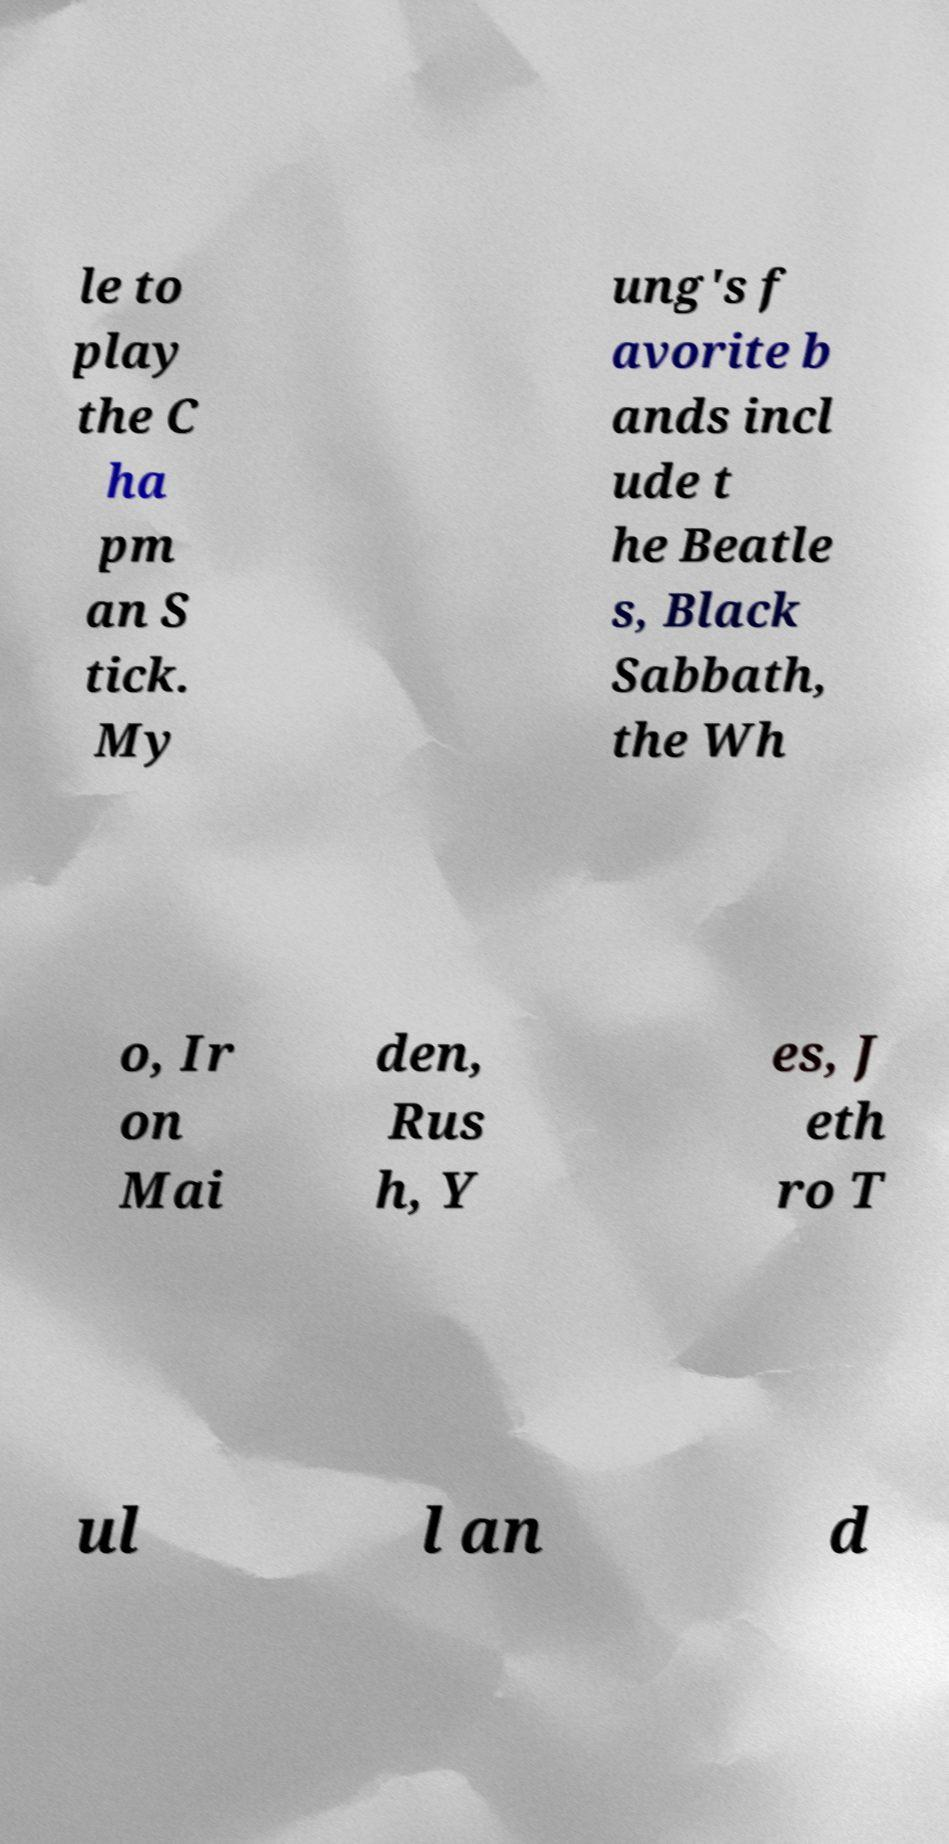Could you extract and type out the text from this image? le to play the C ha pm an S tick. My ung's f avorite b ands incl ude t he Beatle s, Black Sabbath, the Wh o, Ir on Mai den, Rus h, Y es, J eth ro T ul l an d 